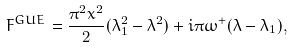<formula> <loc_0><loc_0><loc_500><loc_500>F ^ { G U E } = \frac { \pi ^ { 2 } x ^ { 2 } } { 2 } ( \lambda _ { 1 } ^ { 2 } - \lambda ^ { 2 } ) + i \pi \omega ^ { + } ( \lambda - \lambda _ { 1 } ) ,</formula> 